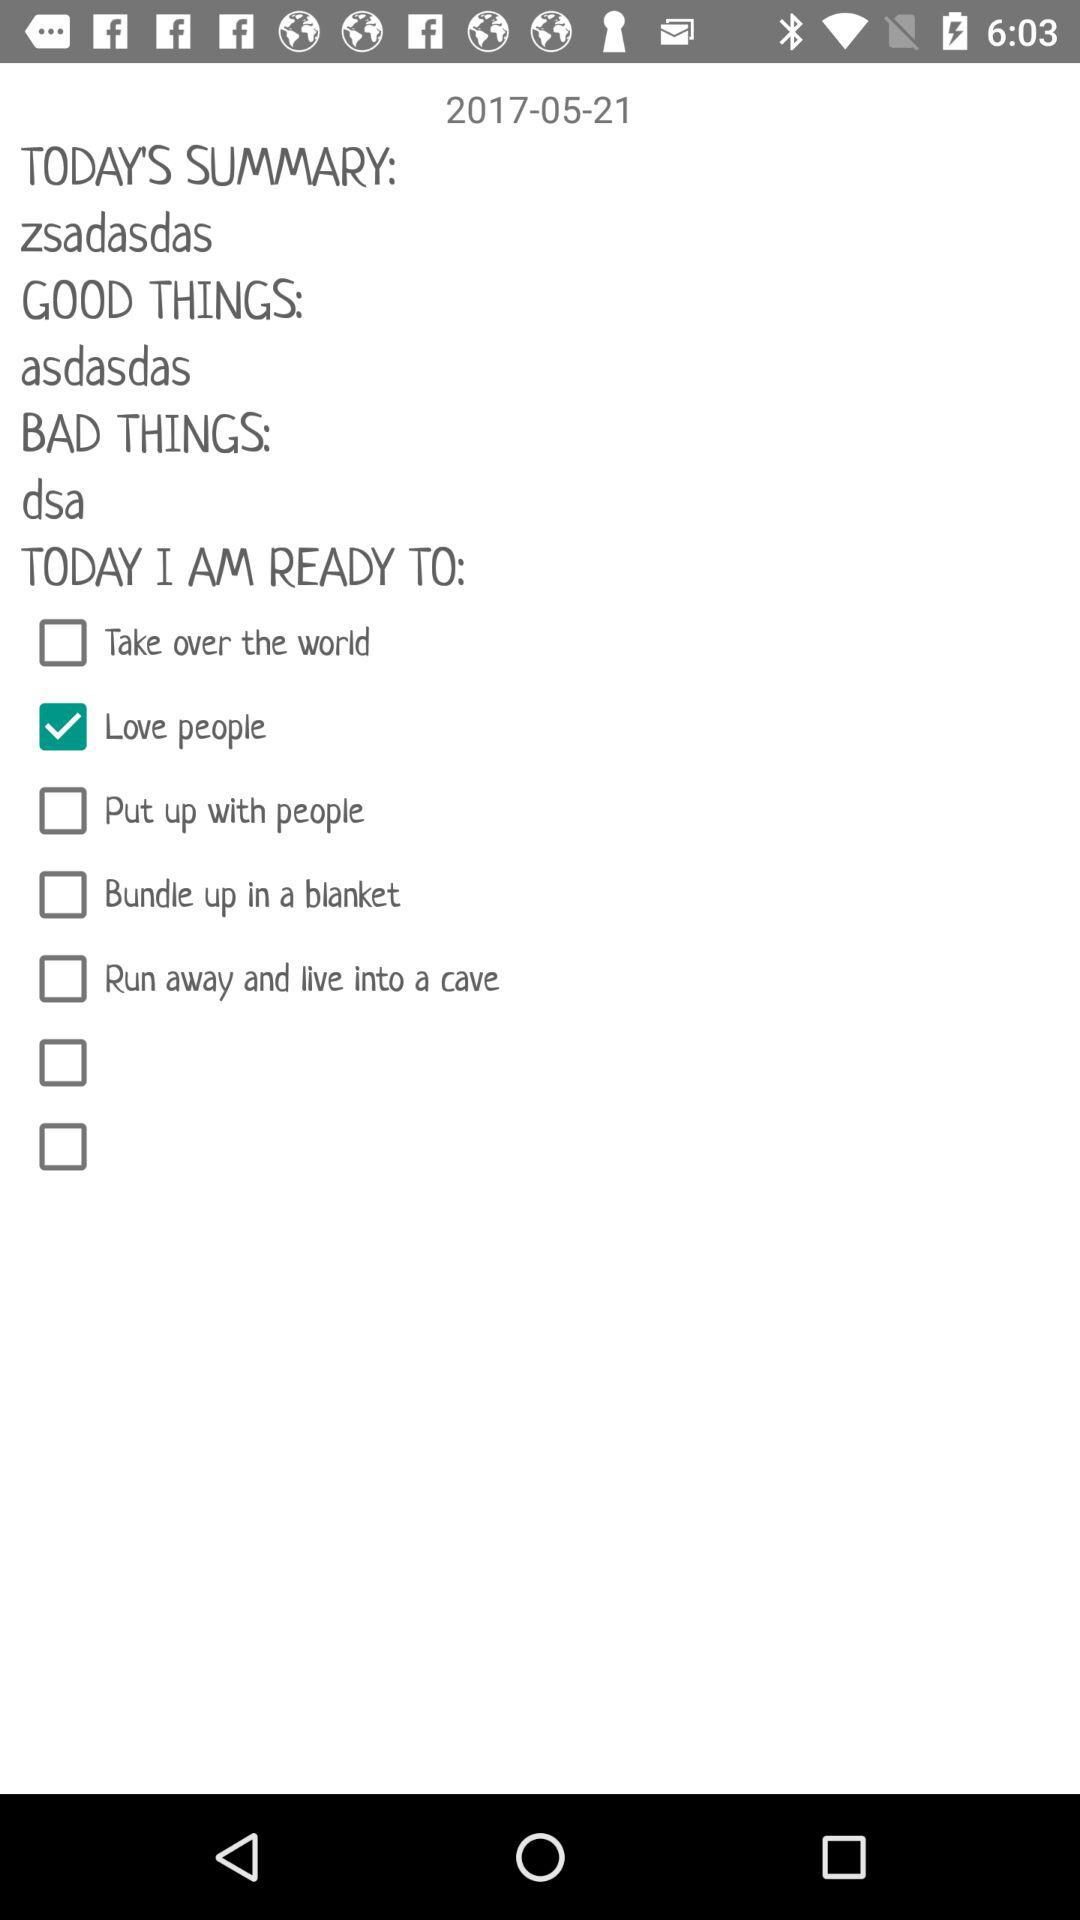What is "TODAY'S SUMMARY"? The today's summary is "zsadasdas". 